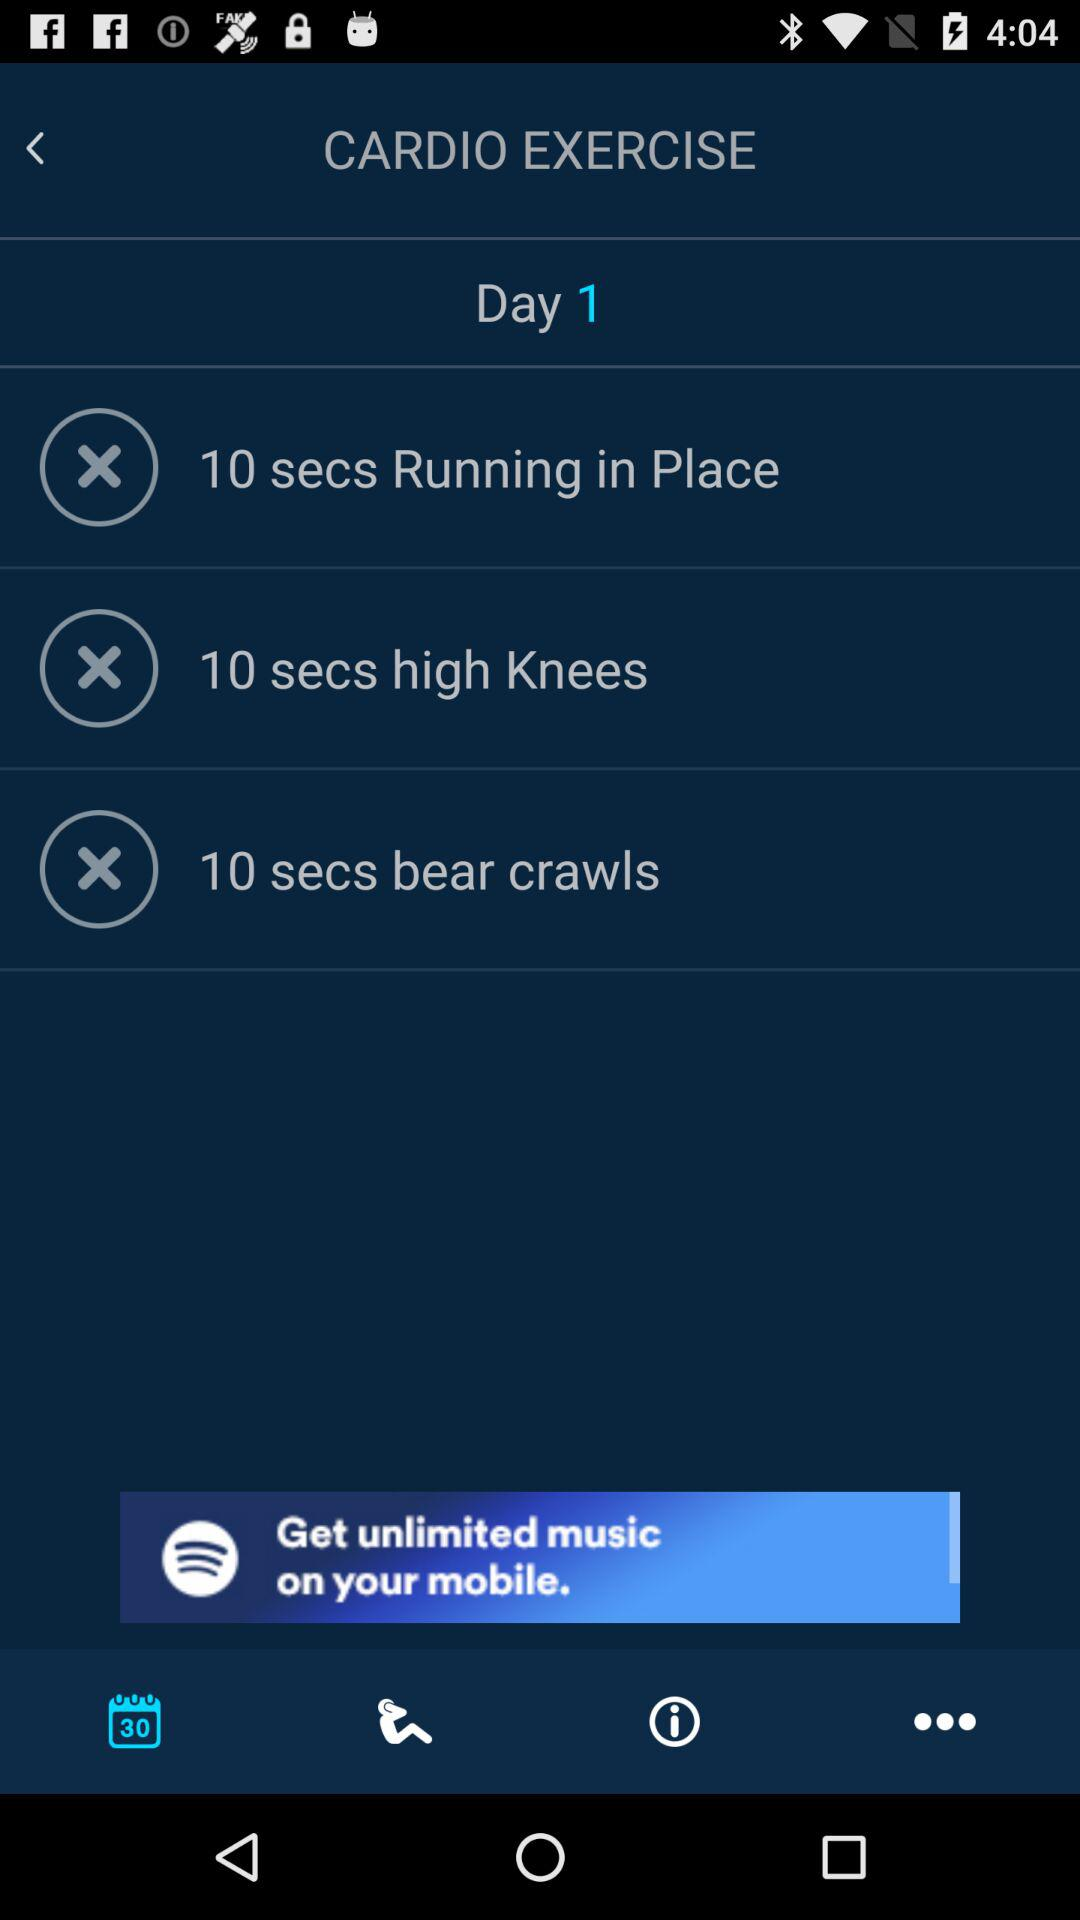What's the time duration for high knees exercise? The time duration for high knees exercise is 10 seconds. 